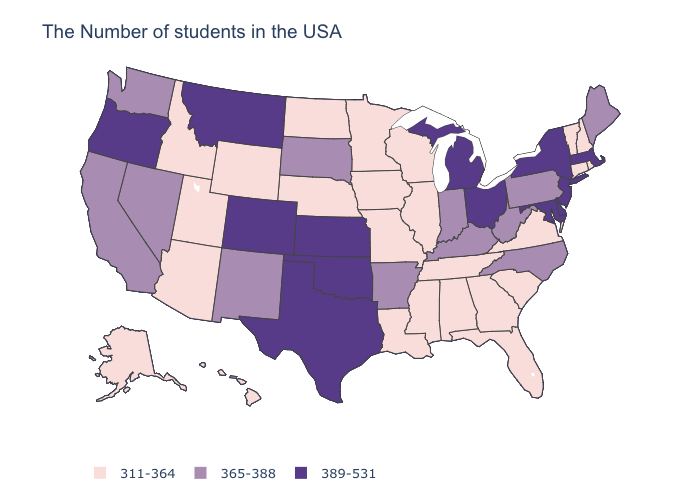Does the map have missing data?
Answer briefly. No. Does New York have the same value as New Hampshire?
Concise answer only. No. What is the highest value in states that border Texas?
Be succinct. 389-531. What is the highest value in states that border South Carolina?
Short answer required. 365-388. Name the states that have a value in the range 311-364?
Short answer required. Rhode Island, New Hampshire, Vermont, Connecticut, Virginia, South Carolina, Florida, Georgia, Alabama, Tennessee, Wisconsin, Illinois, Mississippi, Louisiana, Missouri, Minnesota, Iowa, Nebraska, North Dakota, Wyoming, Utah, Arizona, Idaho, Alaska, Hawaii. Among the states that border Montana , which have the lowest value?
Give a very brief answer. North Dakota, Wyoming, Idaho. What is the value of Utah?
Answer briefly. 311-364. What is the value of Utah?
Quick response, please. 311-364. What is the value of Pennsylvania?
Write a very short answer. 365-388. What is the value of Montana?
Concise answer only. 389-531. What is the lowest value in the USA?
Concise answer only. 311-364. Name the states that have a value in the range 365-388?
Concise answer only. Maine, Pennsylvania, North Carolina, West Virginia, Kentucky, Indiana, Arkansas, South Dakota, New Mexico, Nevada, California, Washington. Does Maine have the lowest value in the USA?
Write a very short answer. No. What is the lowest value in the Northeast?
Concise answer only. 311-364. 